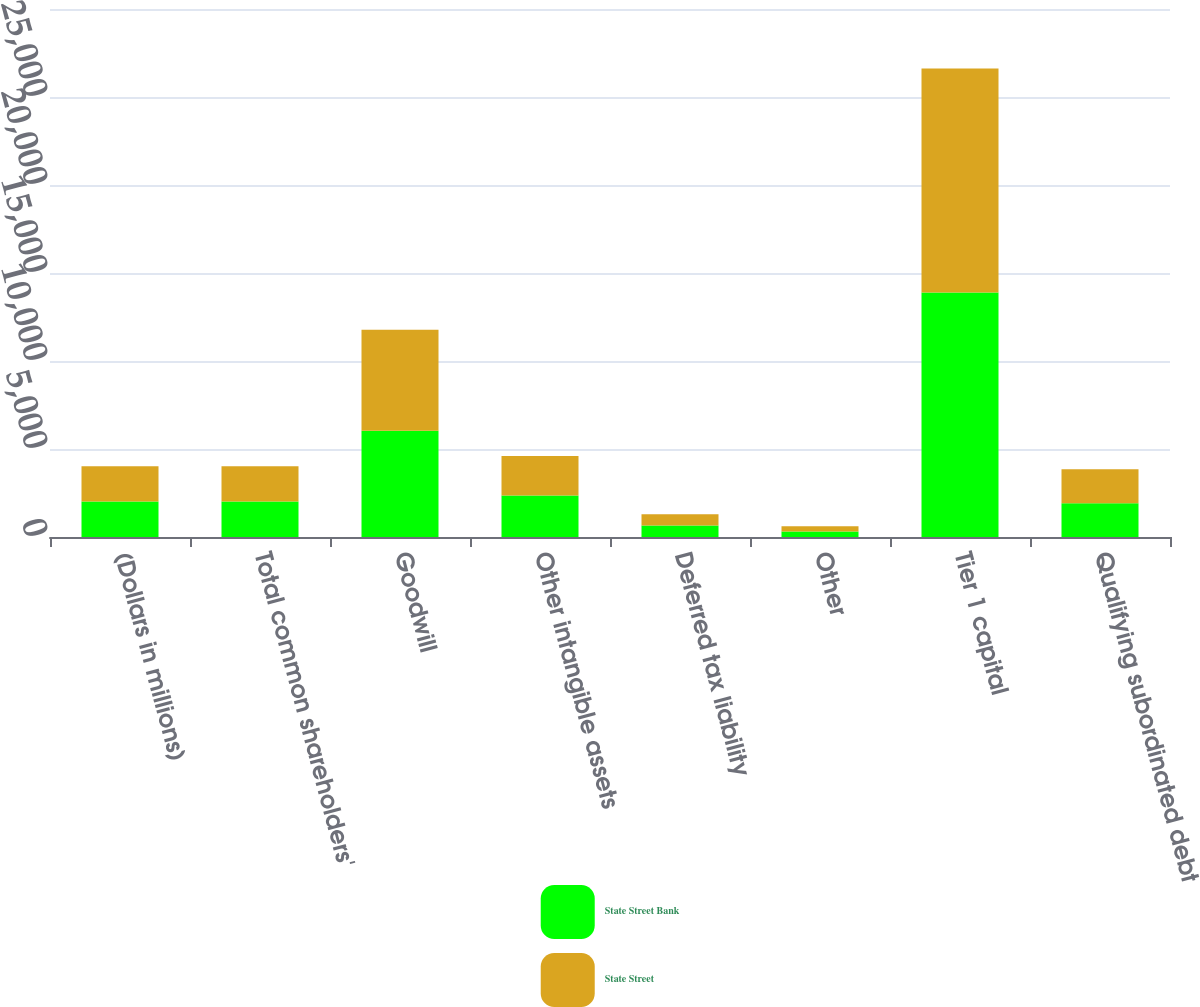Convert chart to OTSL. <chart><loc_0><loc_0><loc_500><loc_500><stacked_bar_chart><ecel><fcel>(Dollars in millions)<fcel>Total common shareholders'<fcel>Goodwill<fcel>Other intangible assets<fcel>Deferred tax liability<fcel>Other<fcel>Tier 1 capital<fcel>Qualifying subordinated debt<nl><fcel>State Street Bank<fcel>2013<fcel>2013<fcel>6036<fcel>2360<fcel>653<fcel>310<fcel>13895<fcel>1918<nl><fcel>State Street<fcel>2013<fcel>2013<fcel>5740<fcel>2239<fcel>638<fcel>304<fcel>12718<fcel>1936<nl></chart> 